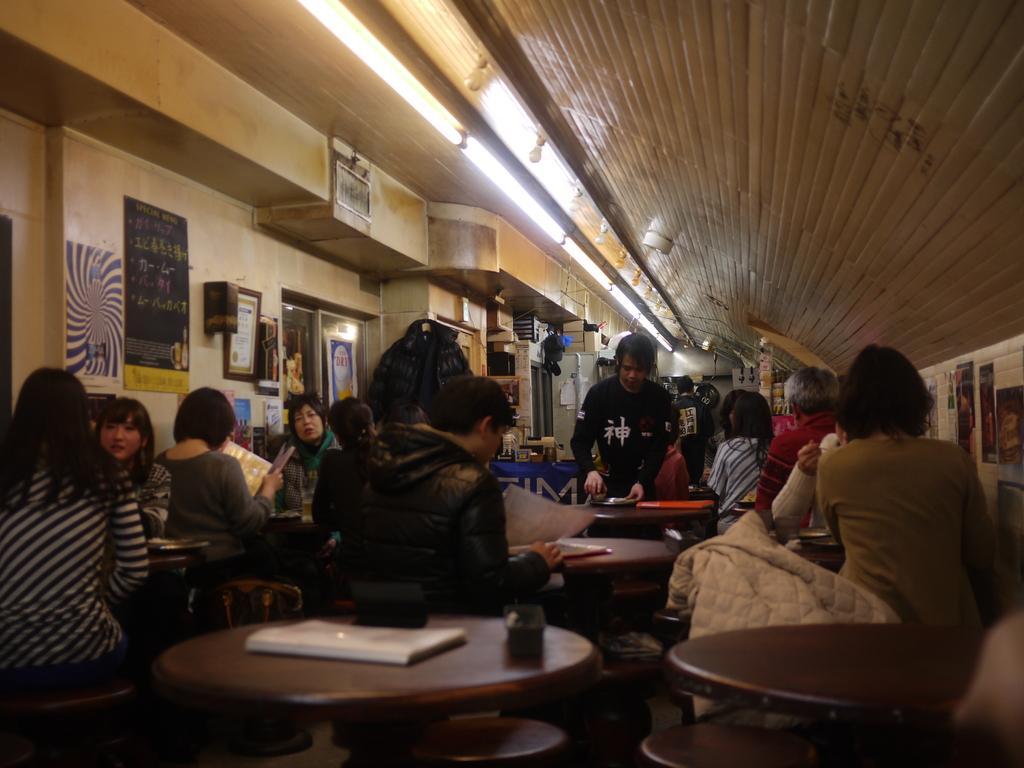Can you describe this image briefly? It seems to be the image is inside the restaurant. In the image there are group of people sitting on chair and looking into a menu card. On left side there is a wall,hoardings,door which is closed, in middle there is a man standing and holding a plate. On right side there are some papers,posters and roof is on top. 